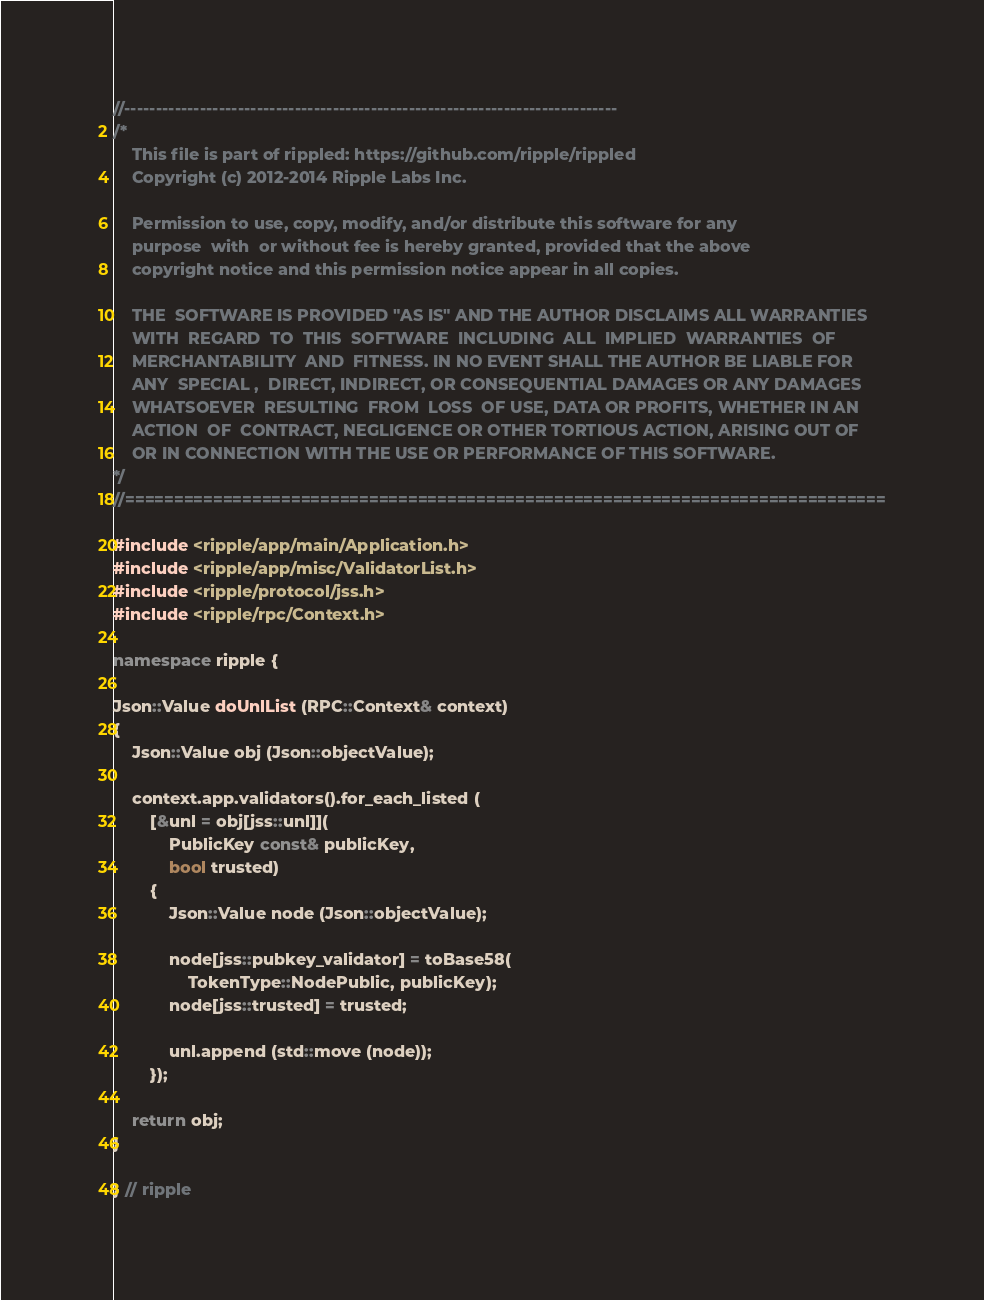Convert code to text. <code><loc_0><loc_0><loc_500><loc_500><_C++_>//------------------------------------------------------------------------------
/*
    This file is part of rippled: https://github.com/ripple/rippled
    Copyright (c) 2012-2014 Ripple Labs Inc.

    Permission to use, copy, modify, and/or distribute this software for any
    purpose  with  or without fee is hereby granted, provided that the above
    copyright notice and this permission notice appear in all copies.

    THE  SOFTWARE IS PROVIDED "AS IS" AND THE AUTHOR DISCLAIMS ALL WARRANTIES
    WITH  REGARD  TO  THIS  SOFTWARE  INCLUDING  ALL  IMPLIED  WARRANTIES  OF
    MERCHANTABILITY  AND  FITNESS. IN NO EVENT SHALL THE AUTHOR BE LIABLE FOR
    ANY  SPECIAL ,  DIRECT, INDIRECT, OR CONSEQUENTIAL DAMAGES OR ANY DAMAGES
    WHATSOEVER  RESULTING  FROM  LOSS  OF USE, DATA OR PROFITS, WHETHER IN AN
    ACTION  OF  CONTRACT, NEGLIGENCE OR OTHER TORTIOUS ACTION, ARISING OUT OF
    OR IN CONNECTION WITH THE USE OR PERFORMANCE OF THIS SOFTWARE.
*/
//==============================================================================

#include <ripple/app/main/Application.h>
#include <ripple/app/misc/ValidatorList.h>
#include <ripple/protocol/jss.h>
#include <ripple/rpc/Context.h>

namespace ripple {

Json::Value doUnlList (RPC::Context& context)
{
    Json::Value obj (Json::objectValue);

    context.app.validators().for_each_listed (
        [&unl = obj[jss::unl]](
            PublicKey const& publicKey,
            bool trusted)
        {
            Json::Value node (Json::objectValue);

            node[jss::pubkey_validator] = toBase58(
                TokenType::NodePublic, publicKey);
            node[jss::trusted] = trusted;

            unl.append (std::move (node));
        });

    return obj;
}

} // ripple
</code> 